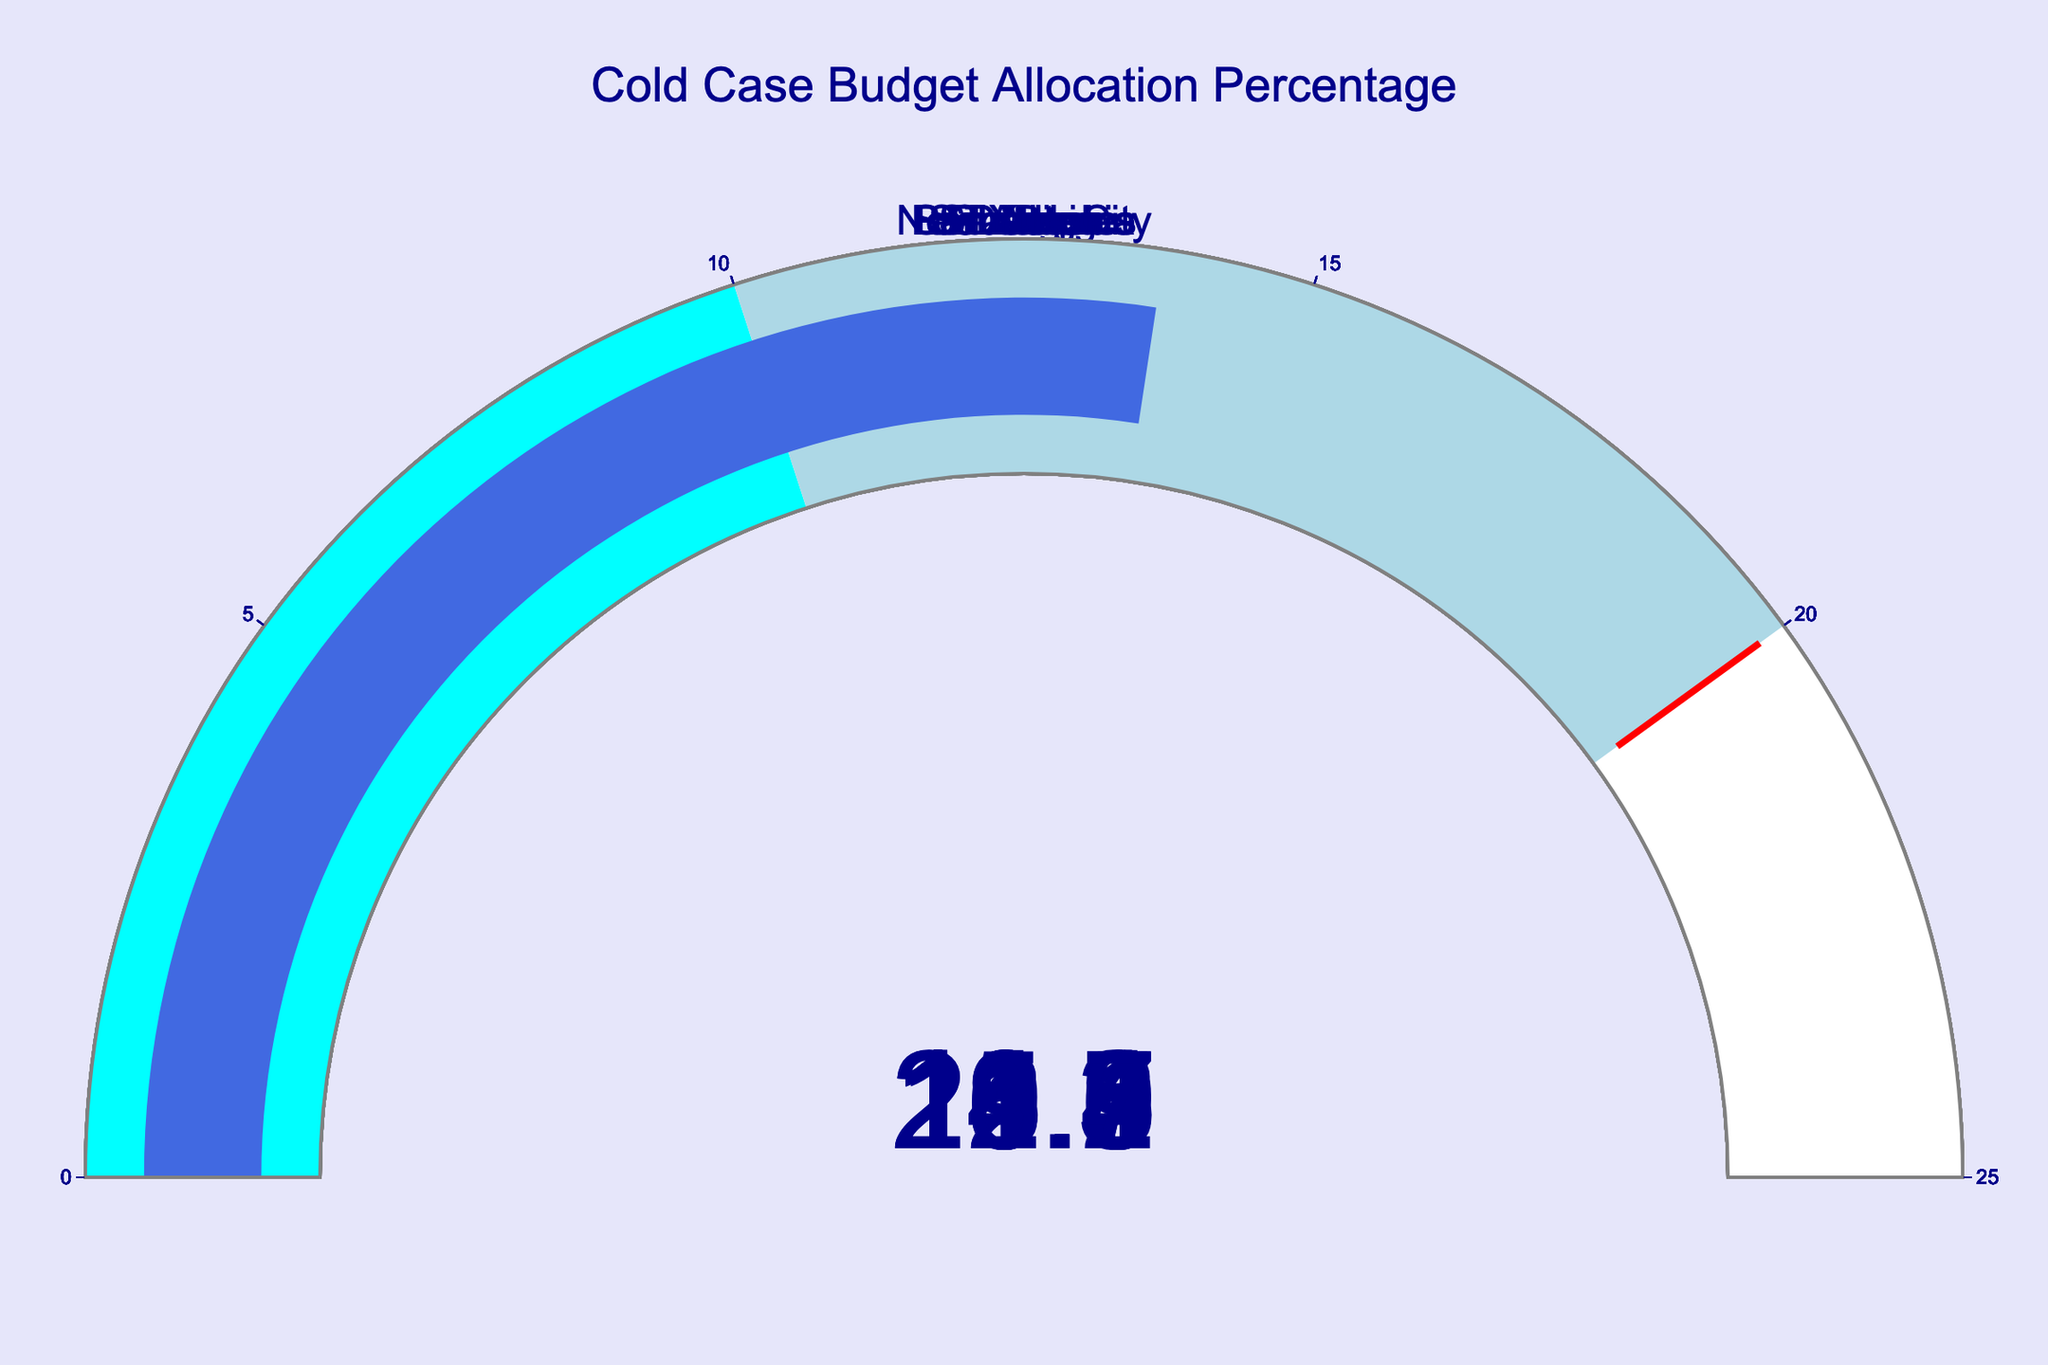What's the title of the figure? The title is located at the top center of the chart in a larger font size. It reads "Cold Case Budget Allocation Percentage".
Answer: Cold Case Budget Allocation Percentage How many cities are represented in the figure? Each gauge represents one city. Count the total number of gauges to determine the number of cities. There are gauges for New York City, Chicago, Los Angeles, Houston, Philadelphia, Phoenix, San Antonio, San Diego, Dallas, and San Jose.
Answer: 10 Which city has the highest percentage allocation for cold cases? Compare the values displayed on the gauges. Los Angeles has the highest percentage with 22.7%.
Answer: Los Angeles Which city has the lowest percentage allocation for cold cases? Compare the values displayed on the gauges. San Antonio has the lowest percentage with 11.3%.
Answer: San Antonio What is the percentage allocation for cold cases in New York City? Locate the gauge for New York City and read the percentage value displayed.
Answer: 18.5 What's the average percentage allocation for all the cities? Sum the percentages for all cities and divide by the number of cities: (18.5 + 15.2 + 22.7 + 12.9 + 20.1 + 14.8 + 11.3 + 19.6 + 16.4 + 13.7) / 10.
Answer: 16.52 Which cities have a percentage allocation above 20%? Identify the gauges with values above 20%. Los Angeles (22.7%) and Philadelphia (20.1%) both fit this criterion.
Answer: Los Angeles, Philadelphia What is the difference in percentage allocation between Phoenix and Dallas? Subtract the percentage of Dallas from that of Phoenix: 14.8% - 16.4%.
Answer: -1.6 Do more cities allocate above or below the average percentage for cold cases? First, calculate the average percentage (16.52%). Count how many cities have percentages above and below this value. More cities are below (6 cities) than above (4 cities).
Answer: Below What's the sum of the percentage allocations for the three cities with the highest values? Identify the top three values: Los Angeles (22.7%), Philadelphia (20.1%), and San Diego (19.6%). Add these percentages together: 22.7 + 20.1 + 19.6 = 62.4.
Answer: 62.4 